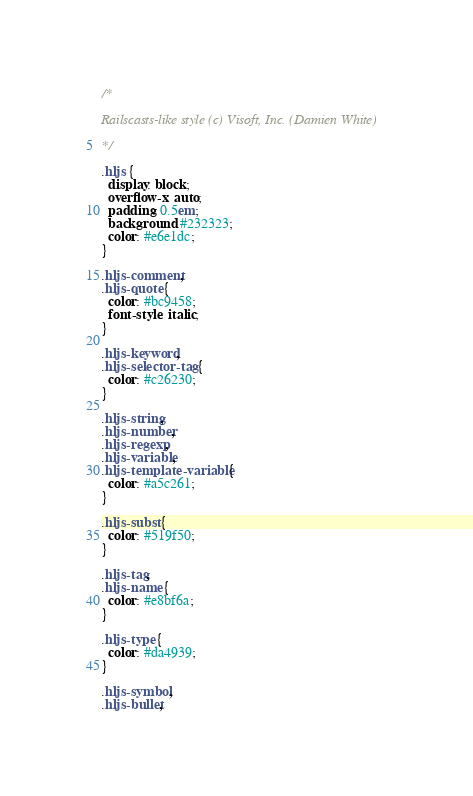<code> <loc_0><loc_0><loc_500><loc_500><_CSS_>/*

Railscasts-like style (c) Visoft, Inc. (Damien White)

*/

.hljs {
  display: block;
  overflow-x: auto;
  padding: 0.5em;
  background: #232323;
  color: #e6e1dc;
}

.hljs-comment,
.hljs-quote {
  color: #bc9458;
  font-style: italic;
}

.hljs-keyword,
.hljs-selector-tag {
  color: #c26230;
}

.hljs-string,
.hljs-number,
.hljs-regexp,
.hljs-variable,
.hljs-template-variable {
  color: #a5c261;
}

.hljs-subst {
  color: #519f50;
}

.hljs-tag,
.hljs-name {
  color: #e8bf6a;
}

.hljs-type {
  color: #da4939;
}

.hljs-symbol,
.hljs-bullet,</code> 